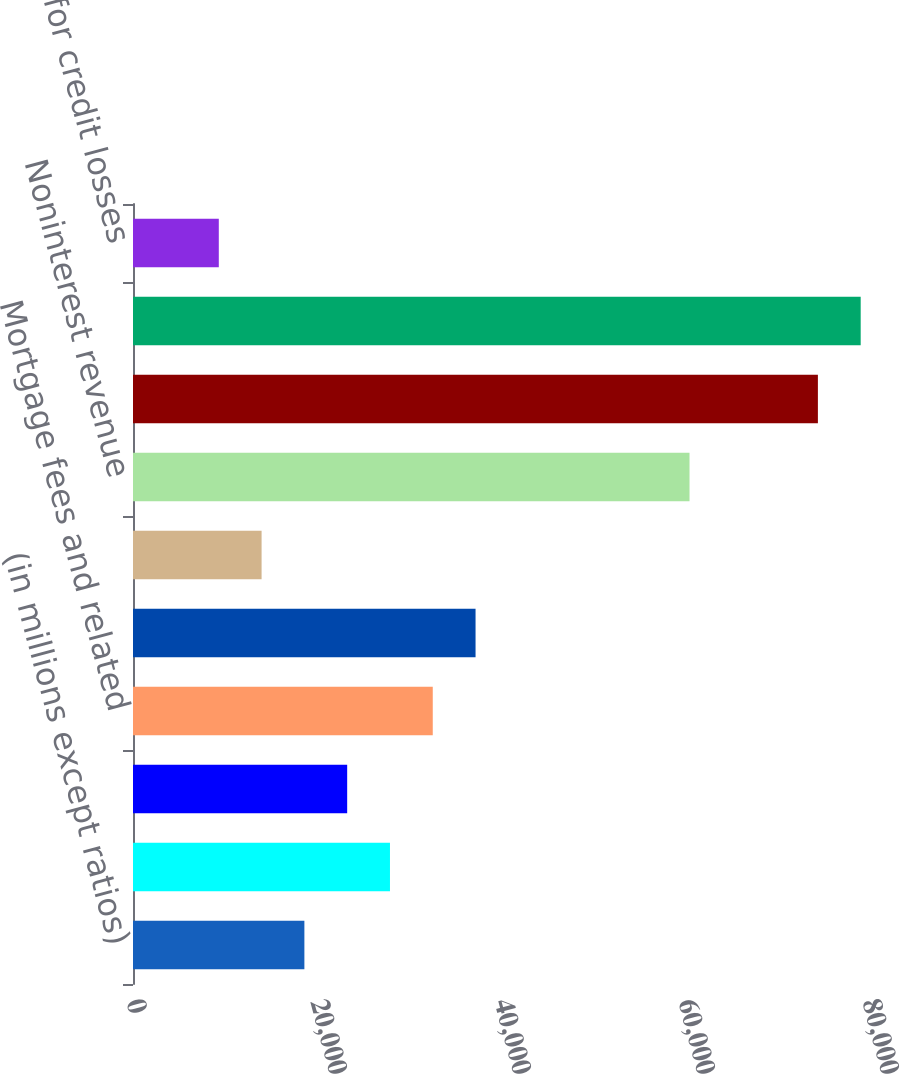Convert chart to OTSL. <chart><loc_0><loc_0><loc_500><loc_500><bar_chart><fcel>(in millions except ratios)<fcel>Lending- and deposit-related<fcel>Asset management<fcel>Mortgage fees and related<fcel>Card income<fcel>All other income<fcel>Noninterest revenue<fcel>Net interest income<fcel>Total net revenue<fcel>Provision for credit losses<nl><fcel>18628.6<fcel>27931.4<fcel>23280<fcel>32582.8<fcel>37234.2<fcel>13977.2<fcel>60491.2<fcel>74445.4<fcel>79096.8<fcel>9325.8<nl></chart> 